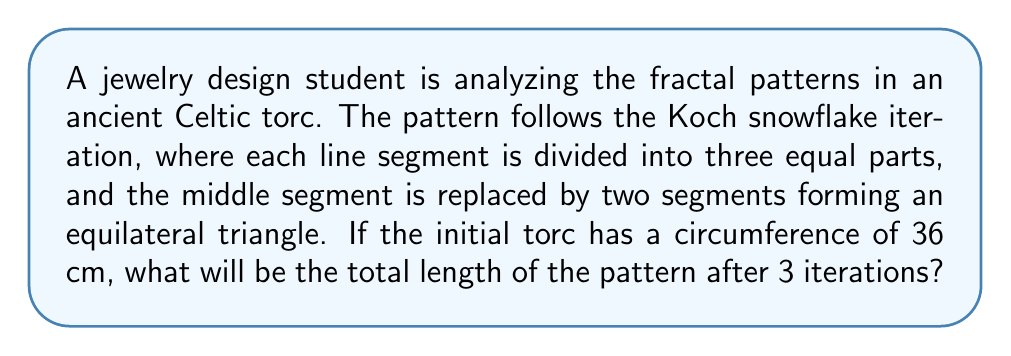What is the answer to this math problem? To solve this problem, we need to follow these steps:

1. Understand the Koch snowflake iteration:
   Each iteration increases the length by a factor of 4/3.

2. Calculate the length after each iteration:
   - Initial length: $L_0 = 36$ cm
   - After 1st iteration: $L_1 = L_0 \cdot \frac{4}{3} = 36 \cdot \frac{4}{3} = 48$ cm
   - After 2nd iteration: $L_2 = L_1 \cdot \frac{4}{3} = 48 \cdot \frac{4}{3} = 64$ cm
   - After 3rd iteration: $L_3 = L_2 \cdot \frac{4}{3} = 64 \cdot \frac{4}{3} = 85.33$ cm

3. Alternatively, we can use the general formula:
   $$L_n = L_0 \cdot \left(\frac{4}{3}\right)^n$$
   where $n$ is the number of iterations.

   For 3 iterations:
   $$L_3 = 36 \cdot \left(\frac{4}{3}\right)^3 = 36 \cdot \frac{64}{27} = 85.33\text{ cm}$$

Therefore, after 3 iterations, the total length of the pattern will be 85.33 cm.
Answer: 85.33 cm 